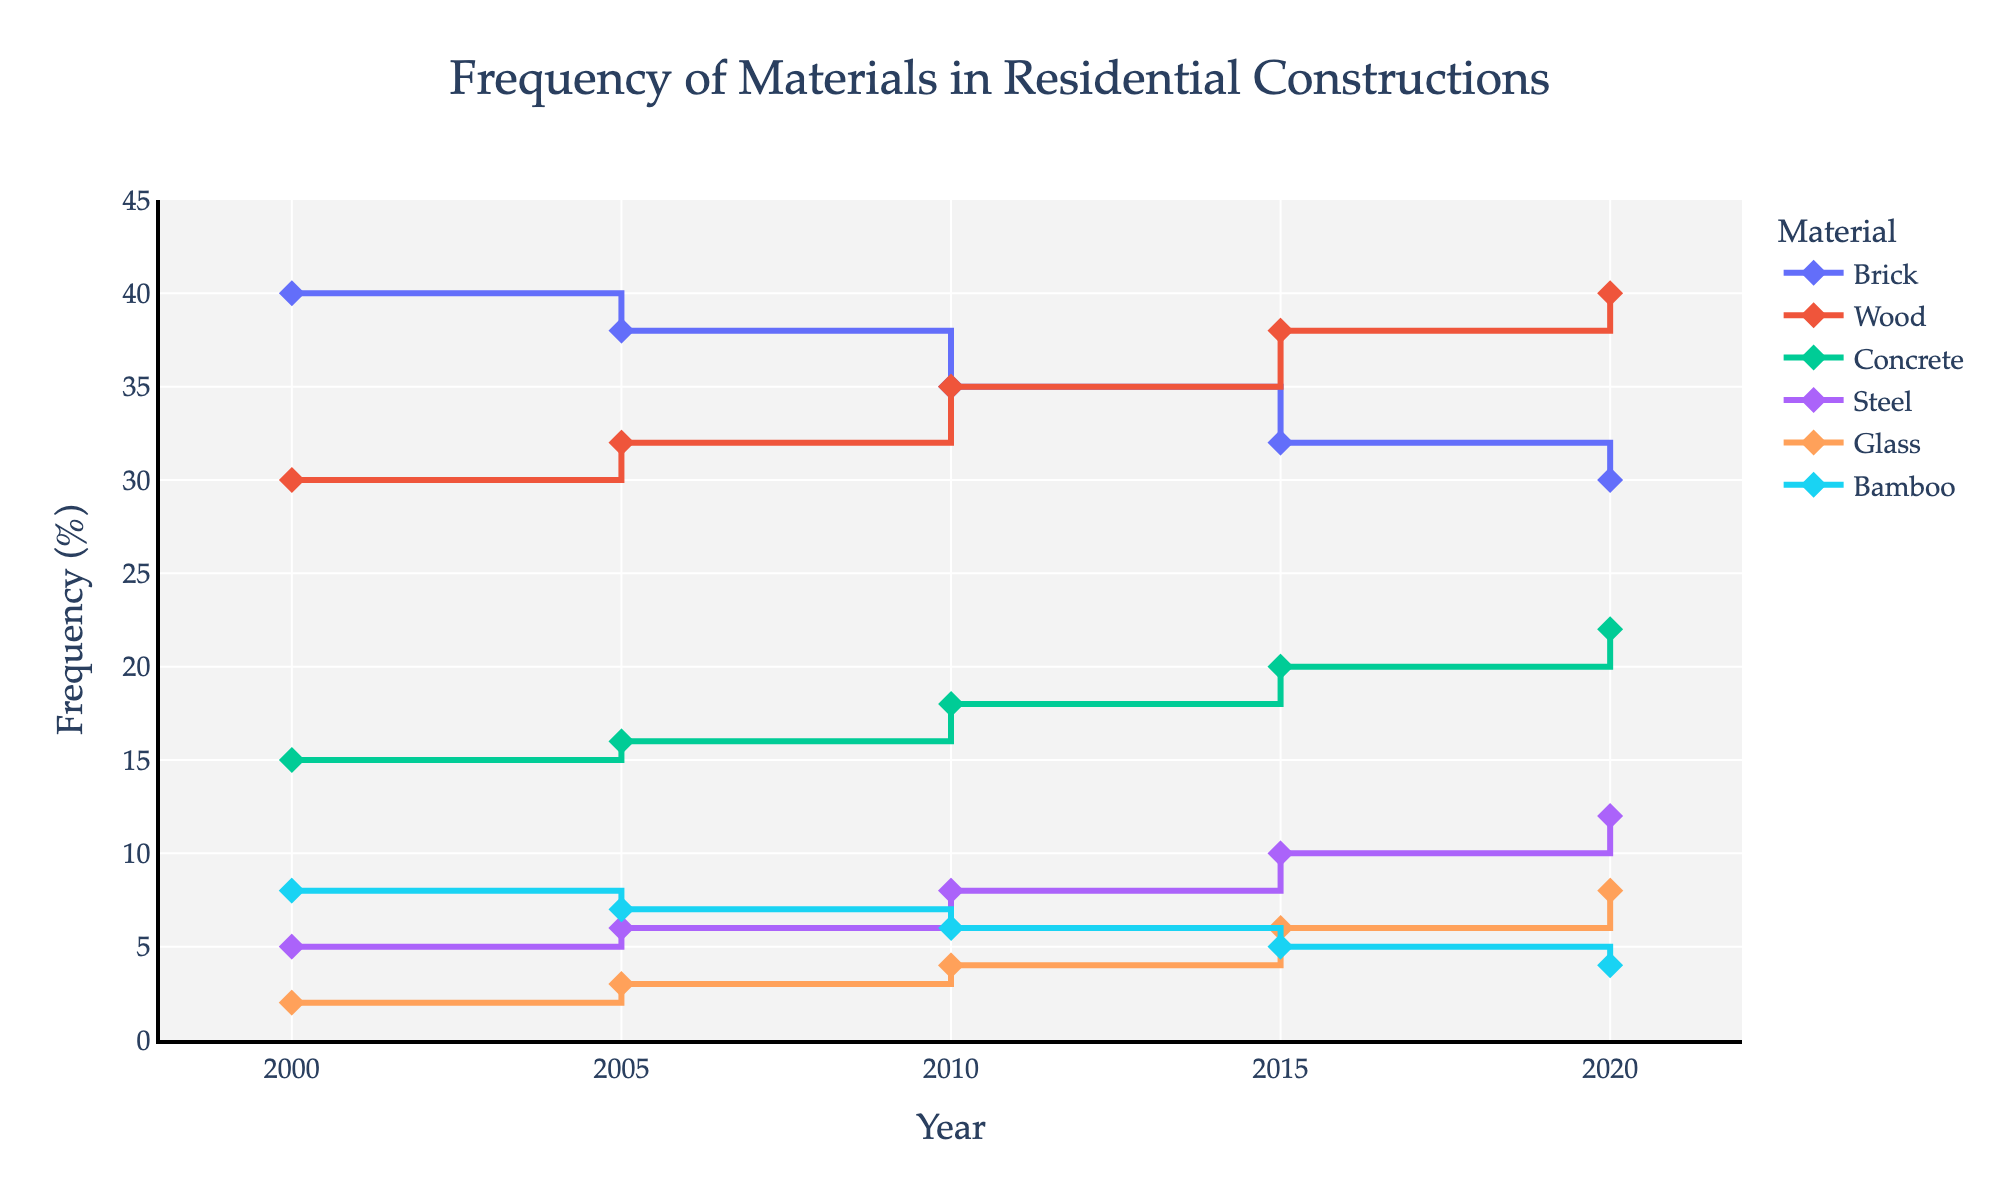What is the title of the plot? The title is located at the top of the plot and provides a concise summary of what the plot represents.
Answer: Frequency of Materials in Residential Constructions What does the x-axis represent? The x-axis title is labeled to indicate the variable it displays over its range of values.
Answer: Year What does the y-axis represent? The y-axis title is labeled to indicate the variable it measures across its range of values.
Answer: Frequency (%) In which year did Glass usage reach 8%? By examining the plot's markers and traces, find the specific year when the Glass trace reaches the 8% level on the y-axis.
Answer: 2020 Which material showed a consistent increase in frequency from 2000 to 2020? Identify the trace that has a continuous upward trend over the entire time period from start to end.
Answer: Wood How many types of materials are tracked in the plot? Counting the unique traces in the plot will provide this number.
Answer: 6 Which year had the highest frequency of Wood usage? By looking at the trace for Wood, identify the year where Wood's frequency reaches its peak.
Answer: 2020 What is the difference in frequency of Bamboo usage between 2000 and 2020? Find the frequency percentage for Bamboo in 2000 and 2020 and subtract the latter from the former for the difference.
Answer: 4 Which material experienced a declining trend over the years? Identify the trace that shows a consistent downward trend from the start year to the end year.
Answer: Bamboo, Brick If you average the frequency of Concrete usage from 2000 to 2020, what is the result? Add the frequency percentages for Concrete for all years presented and divide by the number of years.
Answer: 18.2 